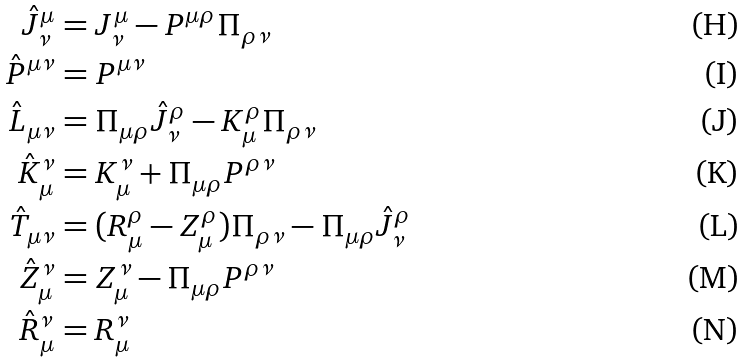Convert formula to latex. <formula><loc_0><loc_0><loc_500><loc_500>\hat { J } ^ { \mu } _ { \nu } & = J ^ { \mu } _ { \nu } - P ^ { \mu \rho } \Pi _ { \rho \nu } \\ \hat { P } ^ { \mu \nu } & = P ^ { \mu \nu } \\ \hat { L } _ { \mu \nu } & = \Pi _ { \mu \rho } \hat { J } ^ { \rho } _ { \nu } - K _ { \mu } ^ { \rho } \Pi _ { \rho \nu } \\ \hat { K } ^ { \nu } _ { \mu } & = K ^ { \nu } _ { \mu } + \Pi _ { \mu \rho } P ^ { \rho \nu } \\ \hat { T } _ { \mu \nu } & = ( R ^ { \rho } _ { \mu } - Z ^ { \rho } _ { \mu } ) \Pi _ { \rho \nu } - \Pi _ { \mu \rho } \hat { J } ^ { \rho } _ { \nu } \\ \hat { Z } ^ { \nu } _ { \mu } & = Z ^ { \nu } _ { \mu } - \Pi _ { \mu \rho } P ^ { \rho \nu } \\ \hat { R } ^ { \nu } _ { \mu } & = R ^ { \nu } _ { \mu }</formula> 